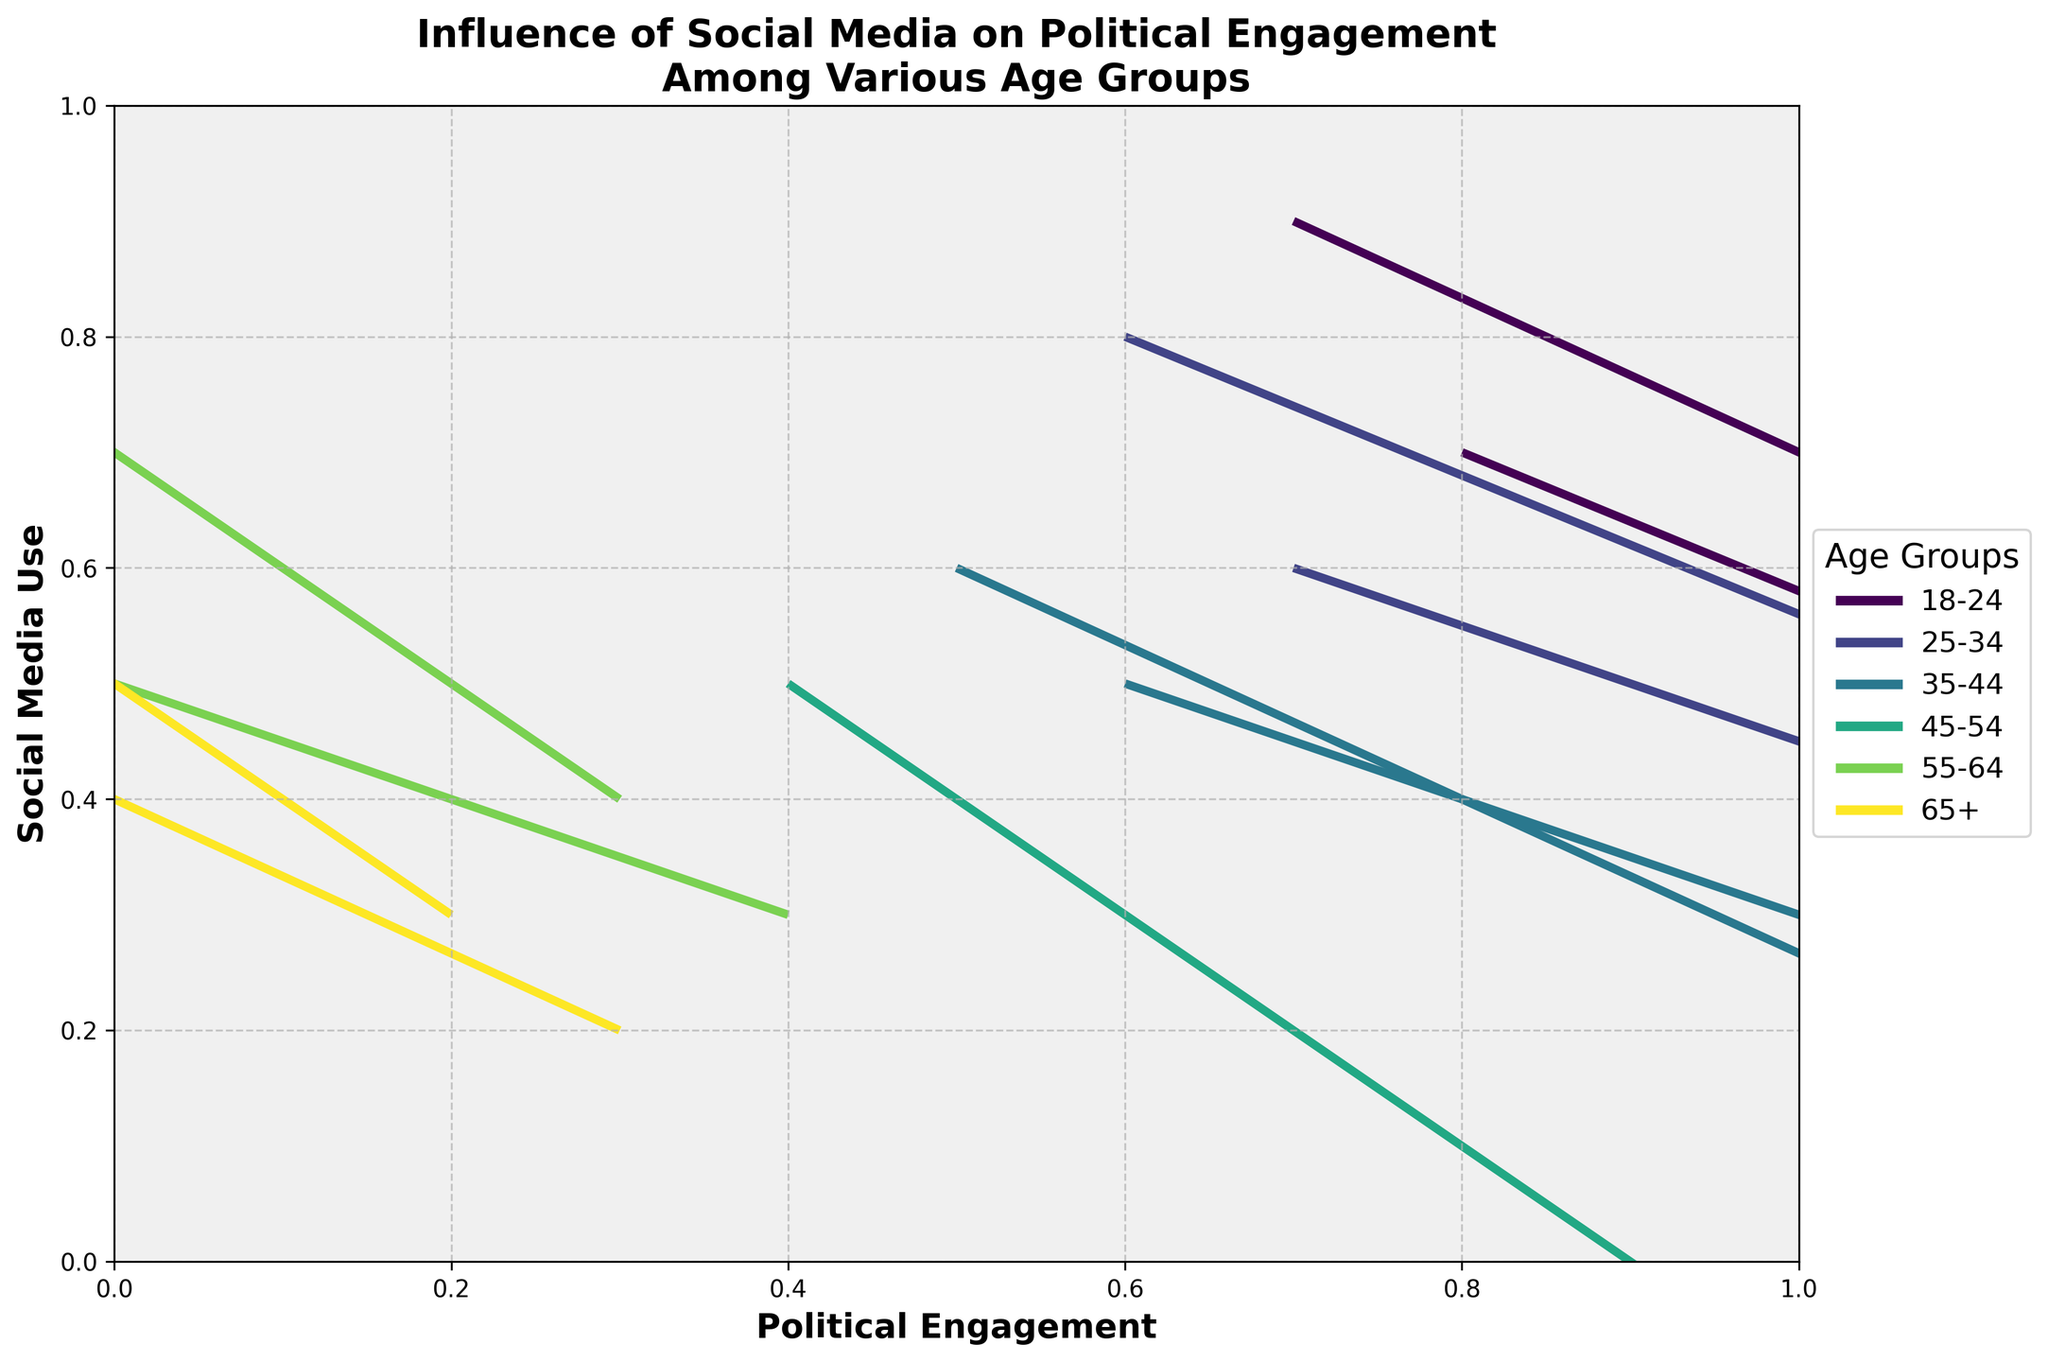What's the title of the figure? The title is found at the top of the figure and summarizes the content and purpose of the chart.
Answer: Influence of Social Media on Political Engagement Among Various Age Groups What's the relationship between the axes? The x-axis represents Political Engagement while the y-axis represents Social Media Use. These axes give an overview of how social media use correlates with political engagement levels.
Answer: Political Engagement on the x-axis and Social Media Use on the y-axis Which age group shows a negative correlation between social media use and political engagement? Look for age groups where the quiver arrows point downwards or leftwards, indicating a decrease in one aspect as the other increases.
Answer: 18-24, 25-34, and 35-44 How does the direction of arrows for the 55-64 age group differ from others? Observe the direction of arrows for each age group and compare. The 55-64 age group has arrows pointing upwards and leftwards.
Answer: Their arrows point upwards and leftwards Compare the overall social media use and political engagement for the 18-24 and 65+ age groups. Compare the positions of the quivers: the 18-24 age group is positioned higher on both axes, indicating higher social media use and political engagement, while the 65+ group is lower on both axes.
Answer: 18-24 has higher social media use and political engagement compared to 65+ Which age group has the highest political engagement? Look at the x-axis values and identify the age group with the highest position.
Answer: 18-24 Does any age group show no movement/change in political engagement with social media use? Identify if any of the arrows remain stationary or don’t indicate movement.
Answer: 45-54 What's the significance of the different colors in the plot? Colors differentiate between the distinct age groups, making it easier to differentiate the data visually.
Answer: Represent different age groups Which age group shows the smallest change in political engagement with increasing social media use? Observe the length and orientation of the arrows; smaller vectors indicate smaller changes.
Answer: 35-44 In the plot, which direction indicates a positive correlation between social media use and political engagement? Positive correlation would mean both variables increase together, so arrows pointing diagonally upwards to the right.
Answer: Diagonally upwards to the right 